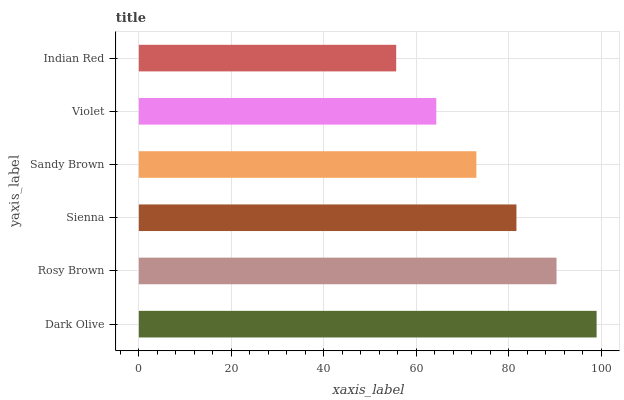Is Indian Red the minimum?
Answer yes or no. Yes. Is Dark Olive the maximum?
Answer yes or no. Yes. Is Rosy Brown the minimum?
Answer yes or no. No. Is Rosy Brown the maximum?
Answer yes or no. No. Is Dark Olive greater than Rosy Brown?
Answer yes or no. Yes. Is Rosy Brown less than Dark Olive?
Answer yes or no. Yes. Is Rosy Brown greater than Dark Olive?
Answer yes or no. No. Is Dark Olive less than Rosy Brown?
Answer yes or no. No. Is Sienna the high median?
Answer yes or no. Yes. Is Sandy Brown the low median?
Answer yes or no. Yes. Is Sandy Brown the high median?
Answer yes or no. No. Is Violet the low median?
Answer yes or no. No. 